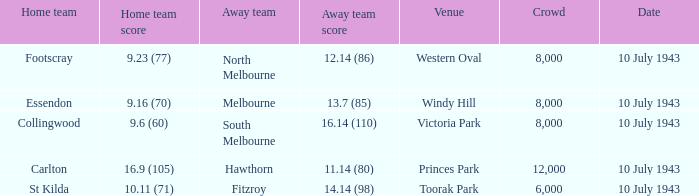When the Home team of carlton played, what was their score? 16.9 (105). 